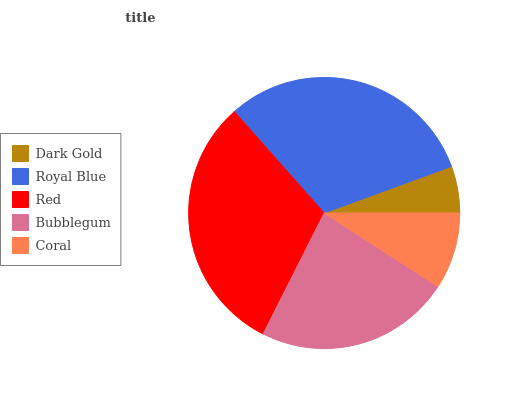Is Dark Gold the minimum?
Answer yes or no. Yes. Is Red the maximum?
Answer yes or no. Yes. Is Royal Blue the minimum?
Answer yes or no. No. Is Royal Blue the maximum?
Answer yes or no. No. Is Royal Blue greater than Dark Gold?
Answer yes or no. Yes. Is Dark Gold less than Royal Blue?
Answer yes or no. Yes. Is Dark Gold greater than Royal Blue?
Answer yes or no. No. Is Royal Blue less than Dark Gold?
Answer yes or no. No. Is Bubblegum the high median?
Answer yes or no. Yes. Is Bubblegum the low median?
Answer yes or no. Yes. Is Coral the high median?
Answer yes or no. No. Is Red the low median?
Answer yes or no. No. 